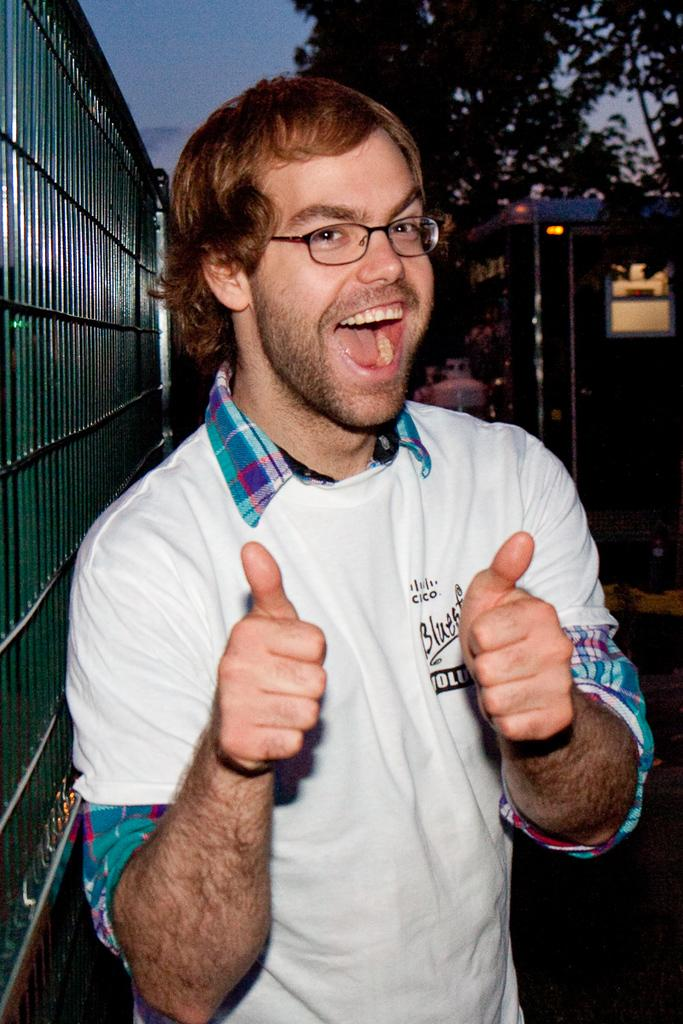Who is the main subject in the image? There is a man in the image. What is the man doing in the image? The man is posing for a camera. Can you describe the man's appearance? The man is wearing spectacles and smiling. What can be seen in the background of the image? There are trees, a fence, and the sky visible in the background of the image. Can you tell me how many donkeys are present in the image? There are no donkeys present in the image; it features a man posing for a camera. What type of cloud is visible in the image? There is no specific cloud mentioned in the image; only the sky is visible in the background. 